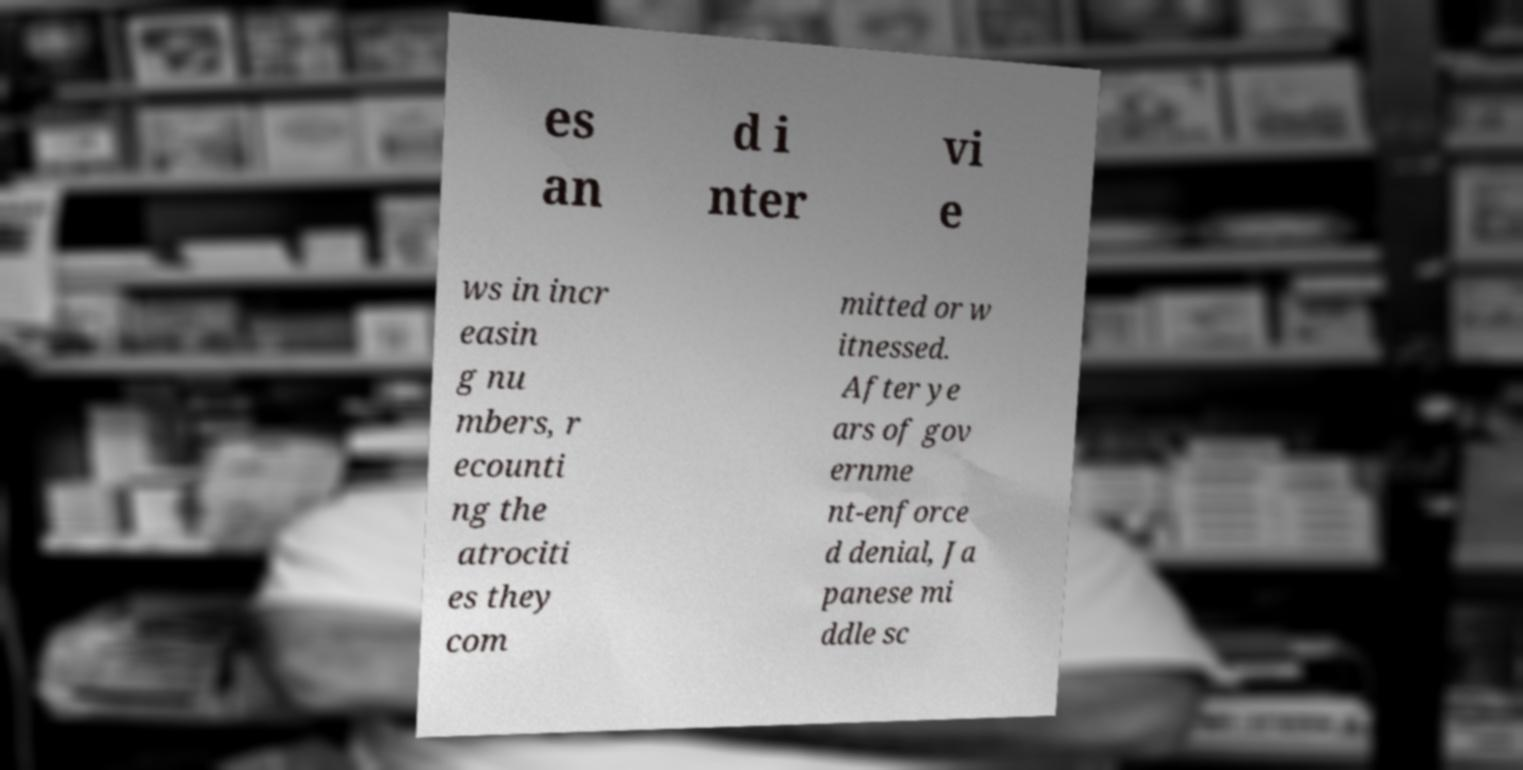I need the written content from this picture converted into text. Can you do that? es an d i nter vi e ws in incr easin g nu mbers, r ecounti ng the atrociti es they com mitted or w itnessed. After ye ars of gov ernme nt-enforce d denial, Ja panese mi ddle sc 